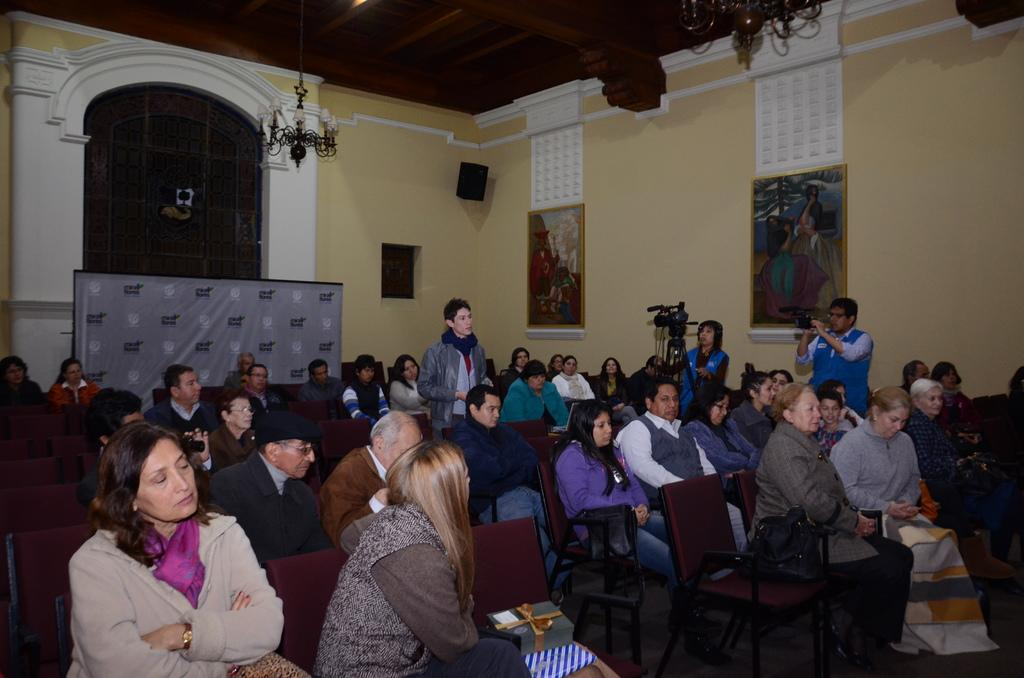What type of structure can be seen in the image? There is a wall in the image. What can be found hanging on the wall? There is a calendar and a photo frame hanging on the wall. What are the people in the image doing? There are people standing and sitting in the image. What furniture is present in the image? There are chairs in the image. What device is visible in the image? There is a camera in the image. How many rabbits can be seen playing with a part of the camera in the image? There are no rabbits or parts of the camera visible in the image. Is there a flame present in the image? No, there is no flame present in the image. 